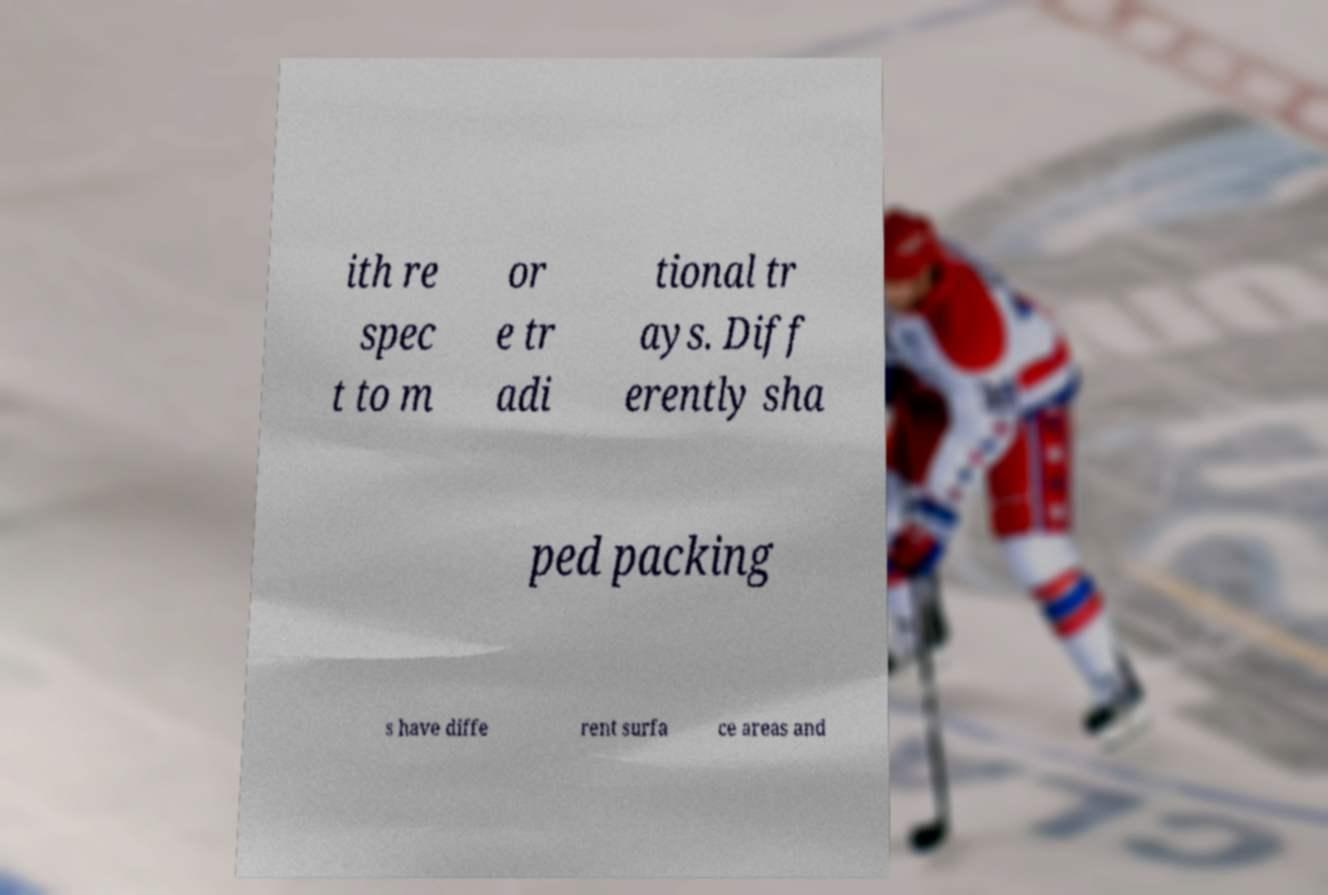Can you read and provide the text displayed in the image?This photo seems to have some interesting text. Can you extract and type it out for me? ith re spec t to m or e tr adi tional tr ays. Diff erently sha ped packing s have diffe rent surfa ce areas and 